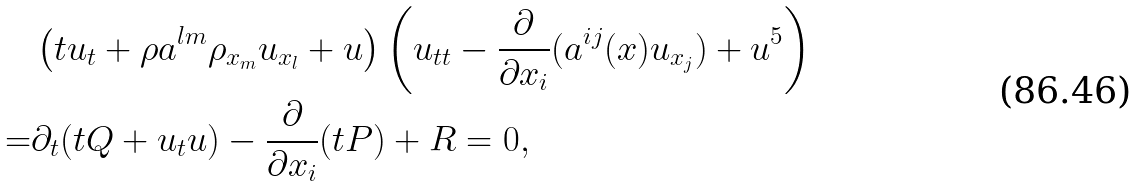Convert formula to latex. <formula><loc_0><loc_0><loc_500><loc_500>& \left ( t u _ { t } + \rho a ^ { l m } \rho _ { x _ { m } } u _ { x _ { l } } + u \right ) \left ( u _ { t t } - \frac { \partial } { \partial x _ { i } } ( a ^ { i j } ( x ) u _ { x _ { j } } ) + u ^ { 5 } \right ) \\ = & \partial _ { t } ( t Q + u _ { t } u ) - \frac { \partial } { \partial x _ { i } } ( t P ) + R = 0 ,</formula> 